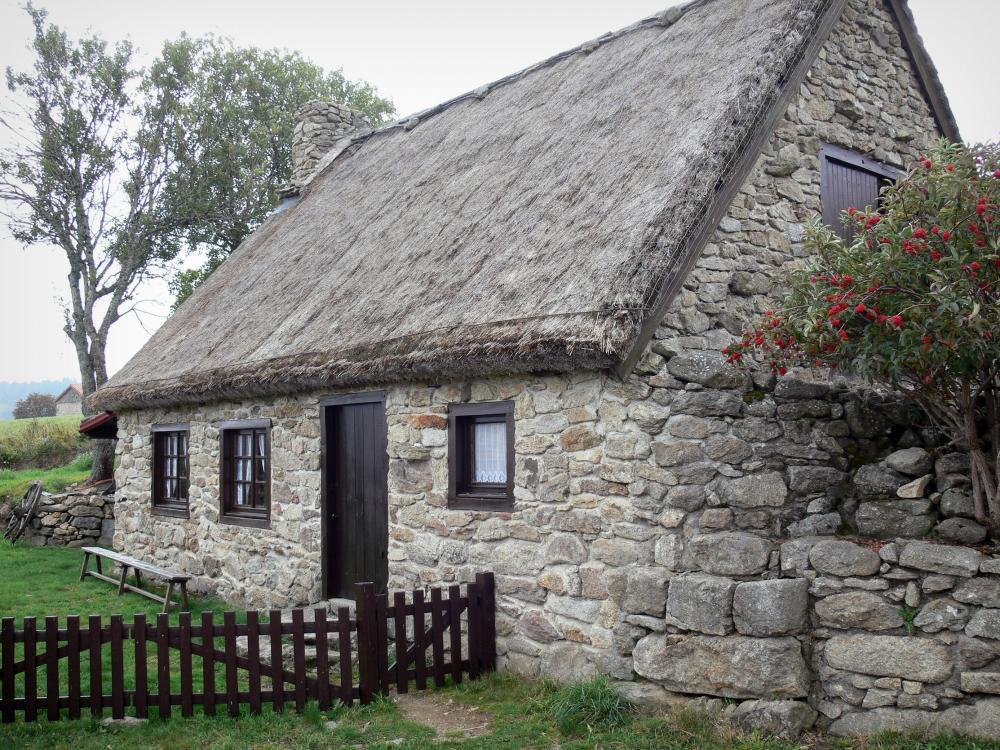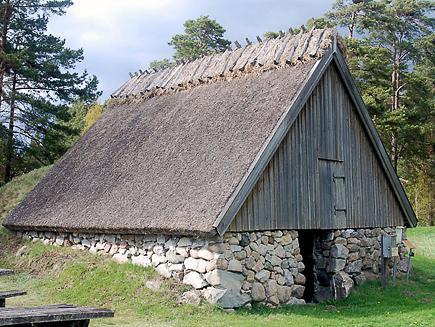The first image is the image on the left, the second image is the image on the right. Evaluate the accuracy of this statement regarding the images: "The left and right image contains the same number of homes with one story of windows.". Is it true? Answer yes or no. No. The first image is the image on the left, the second image is the image on the right. Examine the images to the left and right. Is the description "The right image shows a house with windows featuring different shaped panes below a thick gray roof with a rounded section in front and a scalloped border on the peak edge." accurate? Answer yes or no. No. 